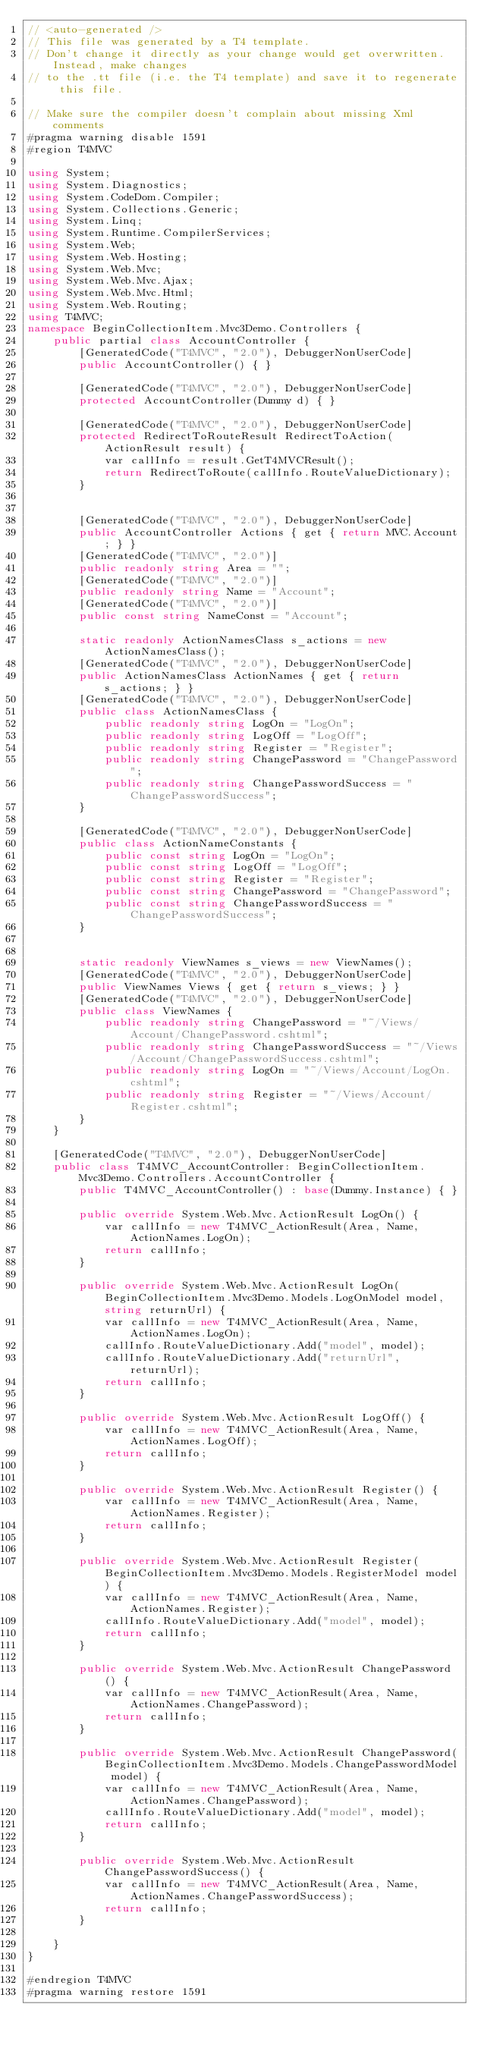<code> <loc_0><loc_0><loc_500><loc_500><_C#_>// <auto-generated />
// This file was generated by a T4 template.
// Don't change it directly as your change would get overwritten.  Instead, make changes
// to the .tt file (i.e. the T4 template) and save it to regenerate this file.

// Make sure the compiler doesn't complain about missing Xml comments
#pragma warning disable 1591
#region T4MVC

using System;
using System.Diagnostics;
using System.CodeDom.Compiler;
using System.Collections.Generic;
using System.Linq;
using System.Runtime.CompilerServices;
using System.Web;
using System.Web.Hosting;
using System.Web.Mvc;
using System.Web.Mvc.Ajax;
using System.Web.Mvc.Html;
using System.Web.Routing;
using T4MVC;
namespace BeginCollectionItem.Mvc3Demo.Controllers {
    public partial class AccountController {
        [GeneratedCode("T4MVC", "2.0"), DebuggerNonUserCode]
        public AccountController() { }

        [GeneratedCode("T4MVC", "2.0"), DebuggerNonUserCode]
        protected AccountController(Dummy d) { }

        [GeneratedCode("T4MVC", "2.0"), DebuggerNonUserCode]
        protected RedirectToRouteResult RedirectToAction(ActionResult result) {
            var callInfo = result.GetT4MVCResult();
            return RedirectToRoute(callInfo.RouteValueDictionary);
        }


        [GeneratedCode("T4MVC", "2.0"), DebuggerNonUserCode]
        public AccountController Actions { get { return MVC.Account; } }
        [GeneratedCode("T4MVC", "2.0")]
        public readonly string Area = "";
        [GeneratedCode("T4MVC", "2.0")]
        public readonly string Name = "Account";
        [GeneratedCode("T4MVC", "2.0")]
        public const string NameConst = "Account";

        static readonly ActionNamesClass s_actions = new ActionNamesClass();
        [GeneratedCode("T4MVC", "2.0"), DebuggerNonUserCode]
        public ActionNamesClass ActionNames { get { return s_actions; } }
        [GeneratedCode("T4MVC", "2.0"), DebuggerNonUserCode]
        public class ActionNamesClass {
            public readonly string LogOn = "LogOn";
            public readonly string LogOff = "LogOff";
            public readonly string Register = "Register";
            public readonly string ChangePassword = "ChangePassword";
            public readonly string ChangePasswordSuccess = "ChangePasswordSuccess";
        }

        [GeneratedCode("T4MVC", "2.0"), DebuggerNonUserCode]
        public class ActionNameConstants {
            public const string LogOn = "LogOn";
            public const string LogOff = "LogOff";
            public const string Register = "Register";
            public const string ChangePassword = "ChangePassword";
            public const string ChangePasswordSuccess = "ChangePasswordSuccess";
        }


        static readonly ViewNames s_views = new ViewNames();
        [GeneratedCode("T4MVC", "2.0"), DebuggerNonUserCode]
        public ViewNames Views { get { return s_views; } }
        [GeneratedCode("T4MVC", "2.0"), DebuggerNonUserCode]
        public class ViewNames {
            public readonly string ChangePassword = "~/Views/Account/ChangePassword.cshtml";
            public readonly string ChangePasswordSuccess = "~/Views/Account/ChangePasswordSuccess.cshtml";
            public readonly string LogOn = "~/Views/Account/LogOn.cshtml";
            public readonly string Register = "~/Views/Account/Register.cshtml";
        }
    }

    [GeneratedCode("T4MVC", "2.0"), DebuggerNonUserCode]
    public class T4MVC_AccountController: BeginCollectionItem.Mvc3Demo.Controllers.AccountController {
        public T4MVC_AccountController() : base(Dummy.Instance) { }

        public override System.Web.Mvc.ActionResult LogOn() {
            var callInfo = new T4MVC_ActionResult(Area, Name, ActionNames.LogOn);
            return callInfo;
        }

        public override System.Web.Mvc.ActionResult LogOn(BeginCollectionItem.Mvc3Demo.Models.LogOnModel model, string returnUrl) {
            var callInfo = new T4MVC_ActionResult(Area, Name, ActionNames.LogOn);
            callInfo.RouteValueDictionary.Add("model", model);
            callInfo.RouteValueDictionary.Add("returnUrl", returnUrl);
            return callInfo;
        }

        public override System.Web.Mvc.ActionResult LogOff() {
            var callInfo = new T4MVC_ActionResult(Area, Name, ActionNames.LogOff);
            return callInfo;
        }

        public override System.Web.Mvc.ActionResult Register() {
            var callInfo = new T4MVC_ActionResult(Area, Name, ActionNames.Register);
            return callInfo;
        }

        public override System.Web.Mvc.ActionResult Register(BeginCollectionItem.Mvc3Demo.Models.RegisterModel model) {
            var callInfo = new T4MVC_ActionResult(Area, Name, ActionNames.Register);
            callInfo.RouteValueDictionary.Add("model", model);
            return callInfo;
        }

        public override System.Web.Mvc.ActionResult ChangePassword() {
            var callInfo = new T4MVC_ActionResult(Area, Name, ActionNames.ChangePassword);
            return callInfo;
        }

        public override System.Web.Mvc.ActionResult ChangePassword(BeginCollectionItem.Mvc3Demo.Models.ChangePasswordModel model) {
            var callInfo = new T4MVC_ActionResult(Area, Name, ActionNames.ChangePassword);
            callInfo.RouteValueDictionary.Add("model", model);
            return callInfo;
        }

        public override System.Web.Mvc.ActionResult ChangePasswordSuccess() {
            var callInfo = new T4MVC_ActionResult(Area, Name, ActionNames.ChangePasswordSuccess);
            return callInfo;
        }

    }
}

#endregion T4MVC
#pragma warning restore 1591
</code> 